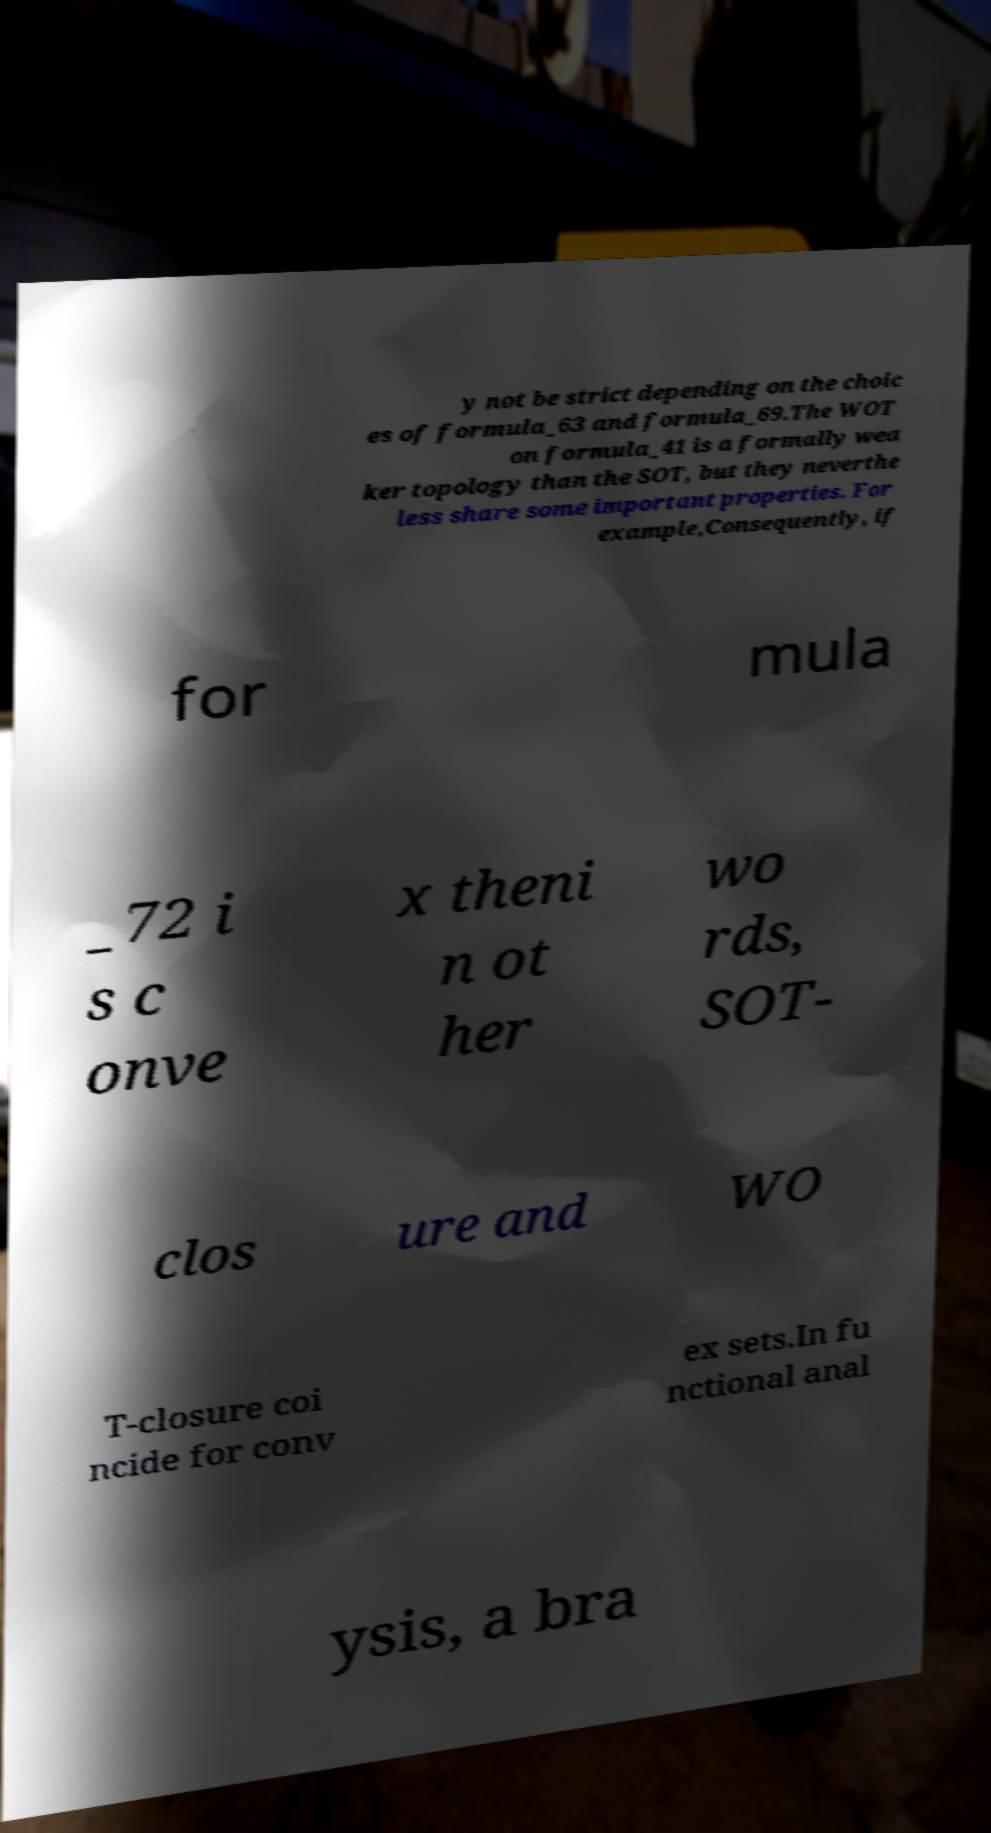For documentation purposes, I need the text within this image transcribed. Could you provide that? y not be strict depending on the choic es of formula_63 and formula_69.The WOT on formula_41 is a formally wea ker topology than the SOT, but they neverthe less share some important properties. For example,Consequently, if for mula _72 i s c onve x theni n ot her wo rds, SOT- clos ure and WO T-closure coi ncide for conv ex sets.In fu nctional anal ysis, a bra 